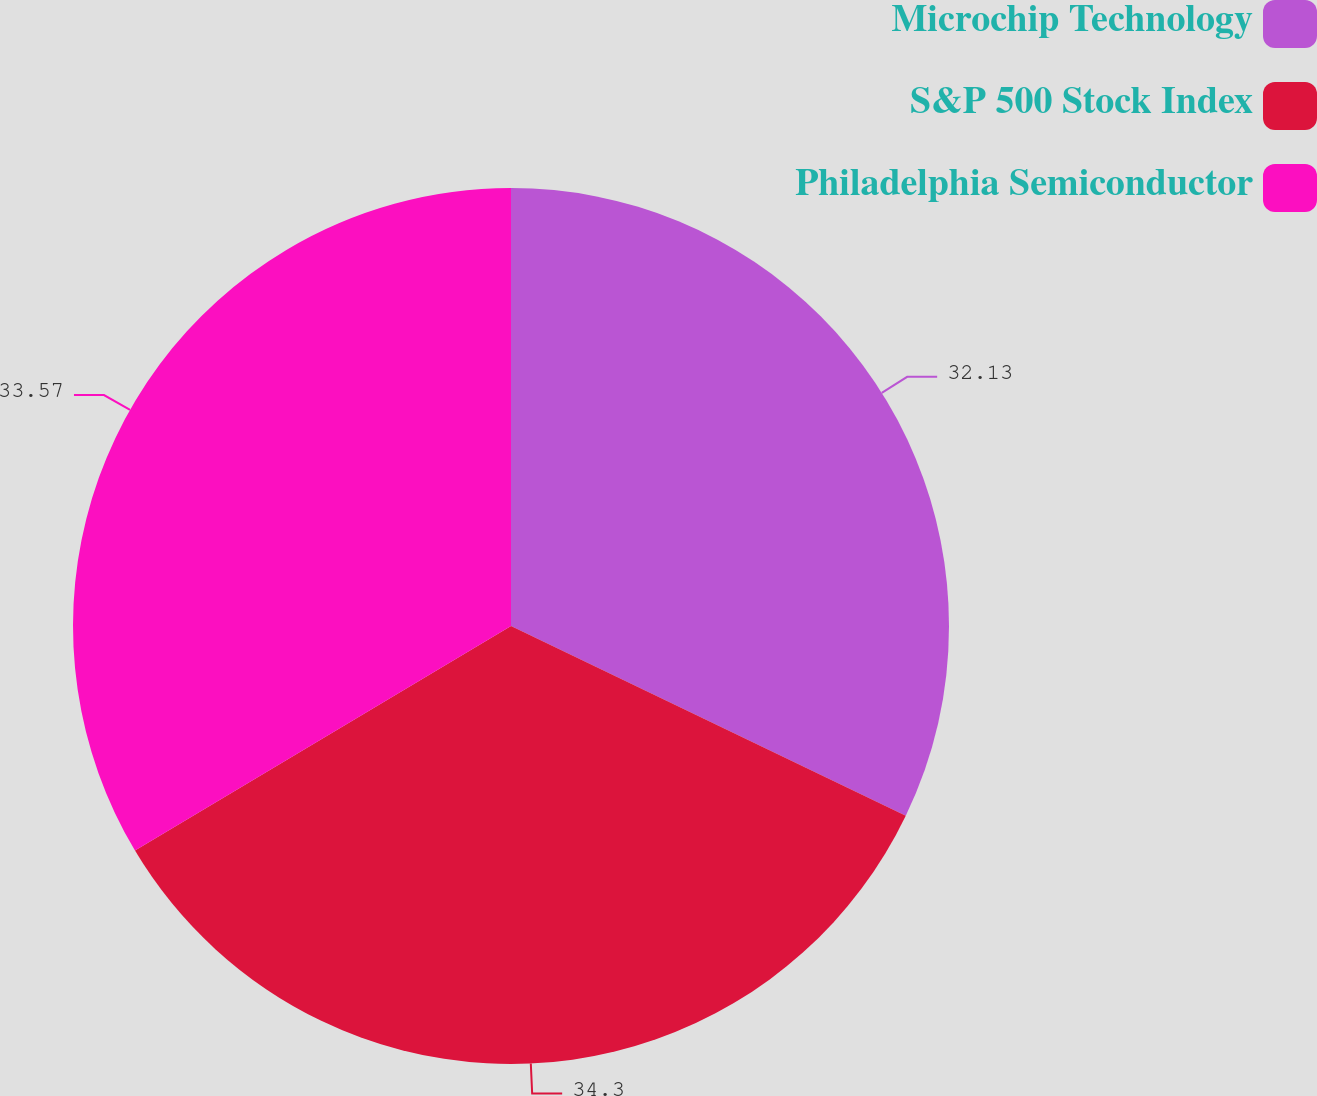Convert chart. <chart><loc_0><loc_0><loc_500><loc_500><pie_chart><fcel>Microchip Technology<fcel>S&P 500 Stock Index<fcel>Philadelphia Semiconductor<nl><fcel>32.13%<fcel>34.3%<fcel>33.57%<nl></chart> 